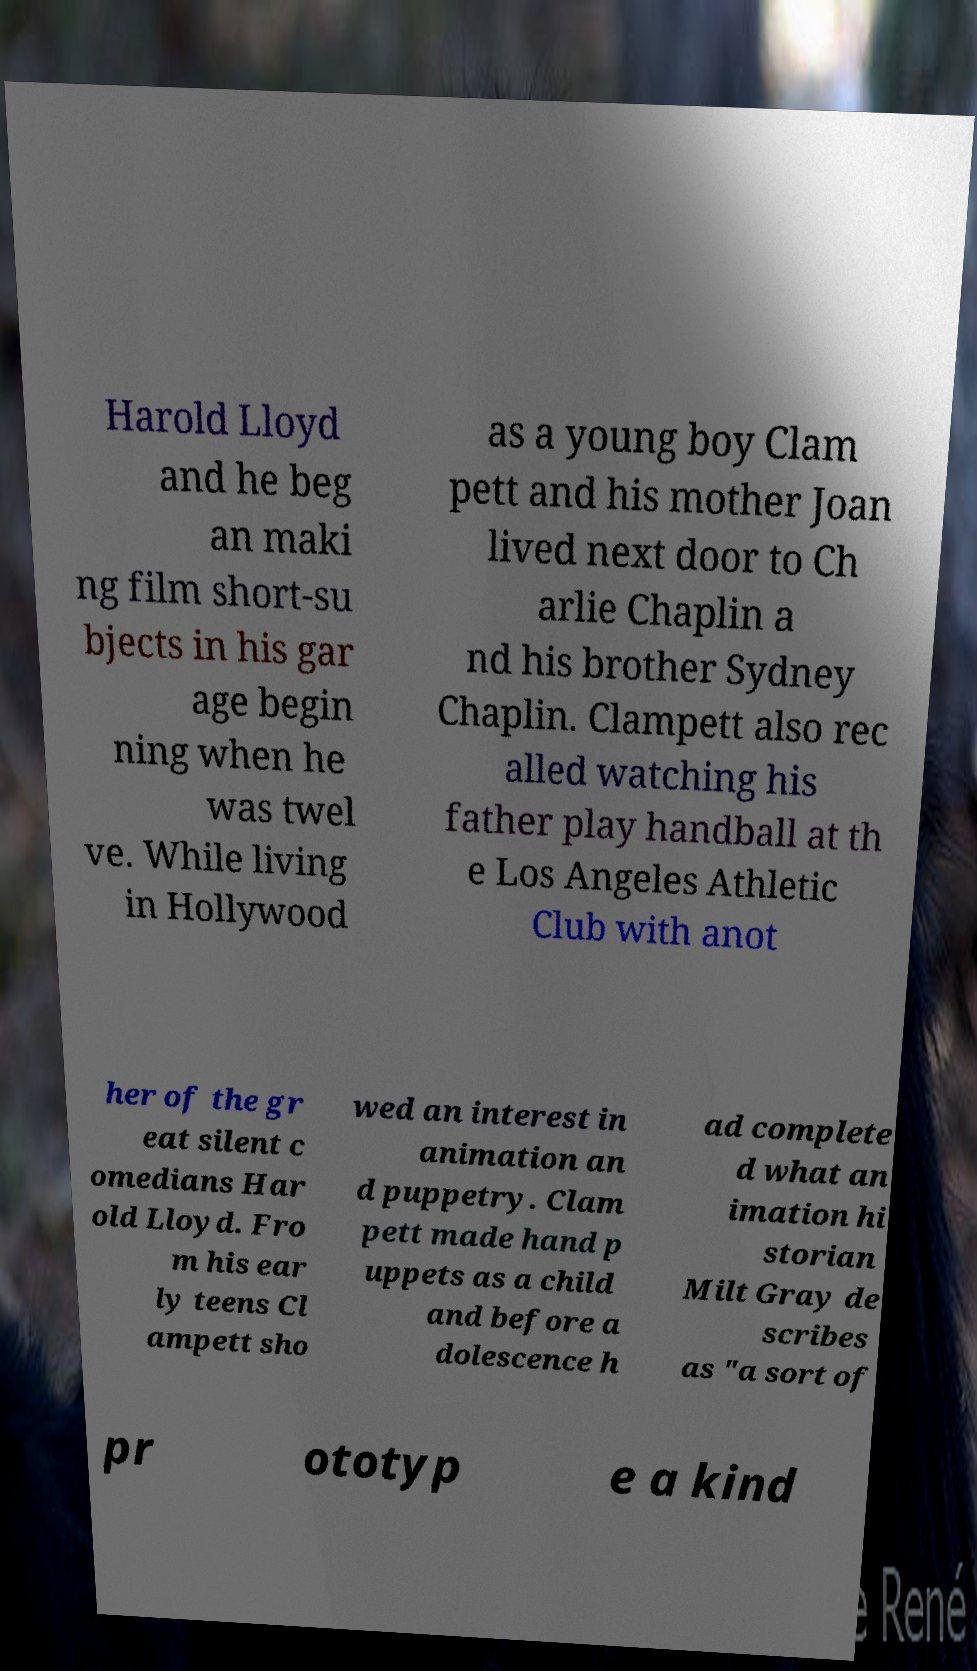I need the written content from this picture converted into text. Can you do that? Harold Lloyd and he beg an maki ng film short-su bjects in his gar age begin ning when he was twel ve. While living in Hollywood as a young boy Clam pett and his mother Joan lived next door to Ch arlie Chaplin a nd his brother Sydney Chaplin. Clampett also rec alled watching his father play handball at th e Los Angeles Athletic Club with anot her of the gr eat silent c omedians Har old Lloyd. Fro m his ear ly teens Cl ampett sho wed an interest in animation an d puppetry. Clam pett made hand p uppets as a child and before a dolescence h ad complete d what an imation hi storian Milt Gray de scribes as "a sort of pr ototyp e a kind 